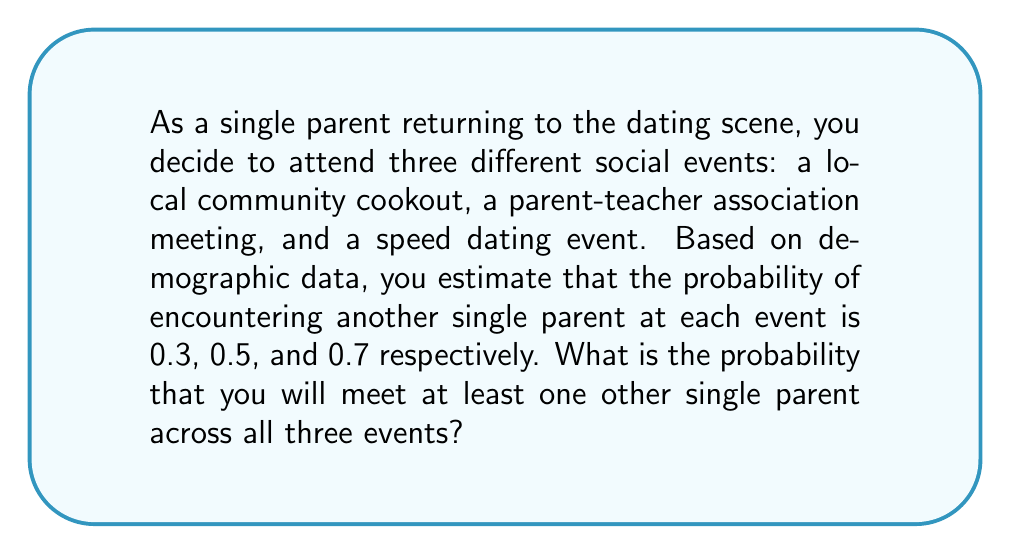Solve this math problem. To solve this problem, we need to use the concept of probability of at least one event occurring, which is the complement of the probability that no events occur.

Let's break it down step-by-step:

1) First, let's define our events:
   A: Meeting a single parent at the cookout (P(A) = 0.3)
   B: Meeting a single parent at the PTA meeting (P(B) = 0.5)
   C: Meeting a single parent at the speed dating event (P(C) = 0.7)

2) We want to find P(at least one), which is equal to 1 - P(none)

3) P(none) is the probability of not meeting a single parent at any of the events:
   P(none) = P(not A and not B and not C)

4) Assuming the events are independent, we can multiply the probabilities:
   P(none) = P(not A) × P(not B) × P(not C)

5) The probability of not meeting a single parent at each event is the complement of meeting one:
   P(not A) = 1 - P(A) = 1 - 0.3 = 0.7
   P(not B) = 1 - P(B) = 1 - 0.5 = 0.5
   P(not C) = 1 - P(C) = 1 - 0.7 = 0.3

6) Now we can calculate P(none):
   P(none) = 0.7 × 0.5 × 0.3 = 0.105

7) Finally, we can calculate P(at least one):
   P(at least one) = 1 - P(none) = 1 - 0.105 = 0.895

Therefore, the probability of meeting at least one single parent across all three events is 0.895 or 89.5%.
Answer: The probability of meeting at least one other single parent across all three events is approximately 0.895 or 89.5%. 